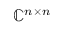Convert formula to latex. <formula><loc_0><loc_0><loc_500><loc_500>\mathbb { C } ^ { n \times n }</formula> 